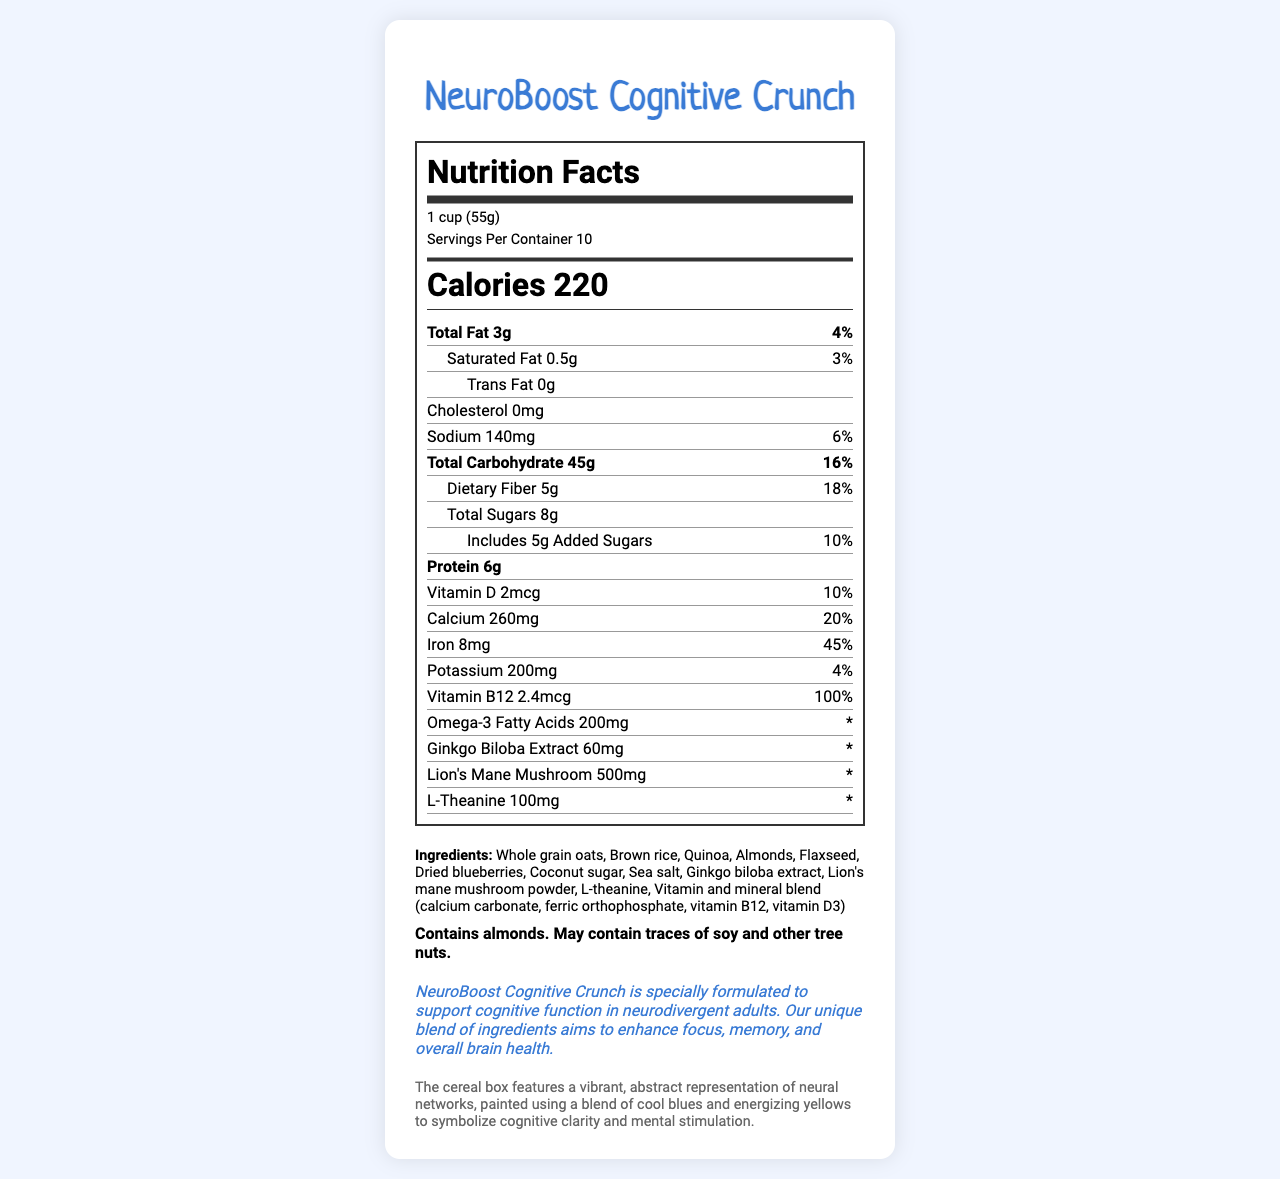what is the serving size of NeuroBoost Cognitive Crunch? The serving size information is displayed at the beginning of the nutrition label under the title "Nutrition Facts".
Answer: 1 cup (55g) how many servings are there per container? The servings per container are listed under the serving size information at the beginning of the nutrition label.
Answer: 10 what is the calorie count per serving? The calorie information is prominently displayed in a bold font in the nutrition label section.
Answer: 220 how much protein does one serving of NeuroBoost Cognitive Crunch contain? The protein content is listed toward the middle of the nutrition label.
Answer: 6g what is the percentage of daily value for iron per serving? The daily value percentage for iron is listed on the nutrition label next to the iron amount.
Answer: 45% how much added sugar is in one serving? A. 3g B. 5g C. 8g The added sugar amount is listed under the total sugars in the nutrition label as 5g which corresponds to 10% of the daily value.
Answer: B which ingredient is not in NeuroBoost Cognitive Crunch? I. Flaxseed II. Whole grain oats III. Peanuts The ingredient list includes flaxseed and whole grain oats but does not mention peanuts.
Answer: III is there any cholesterol in this cereal? The cholesterol content is listed as 0mg in the nutrition label.
Answer: No summarize the document. The document presents comprehensive details about the cereal's nutritional content, cognitive support statement, ingredients, allergen information, and artistic packaging.
Answer: NeuroBoost Cognitive Crunch is a brain-boosting breakfast cereal designed to support cognitive function in neurodivergent adults. The nutrition label provides detailed information about its serving size, calorie count, nutrients, and key ingredients like omega-3 fatty acids, ginkgo biloba extract, lion's mane mushroom, and L-theanine. The cereal is packed with vitamins and minerals, such as vitamin D, calcium, iron, and vitamin B12. The document also includes allergen information and a description of the artistic packaging. what is the total amount of carbohydrates in one serving, including dietary fiber and sugars? The total carbohydrate amount is 45g, plus dietary fiber is 5g and total sugars are 8g, summing up to 58g.
Answer: 58g what is the artistic theme of the cereal's packaging described in the document? The artistic packaging description mentions a vibrant abstract representation of neural networks with cool blues and energizing yellows.
Answer: A vibrant, abstract representation of neural networks how does this cereal support cognitive function in neurodivergent adults? The neurodivergent support statement mentions that the cereal is formulated to support cognitive function with a blend of ingredients like ginkgo biloba extract, lion's mane mushroom, and L-theanine.
Answer: by including ingredients like ginkgo biloba extract, lion's mane mushroom, and L-theanine how much omega-3 fatty acids are in a serving? The amount of omega-3 fatty acids is listed near the end of the nutritional content section in the nutrition label.
Answer: 200mg what is the daily value percentage of potassium per serving? The daily value percentage for potassium is listed next to its amount in the nutrition label.
Answer: 4% does the nutrition label specify the exact benefits of lion’s mane mushroom? The nutrition label only lists the amount of lion's mane mushroom but does not specify its benefits.
Answer: No who is the intended audience for NeuroBoost Cognitive Crunch? The intended audience is mentioned in the neurodivergent support statement, which describes the cereal's formulation for neurodivergent adults.
Answer: neurodivergent adults 